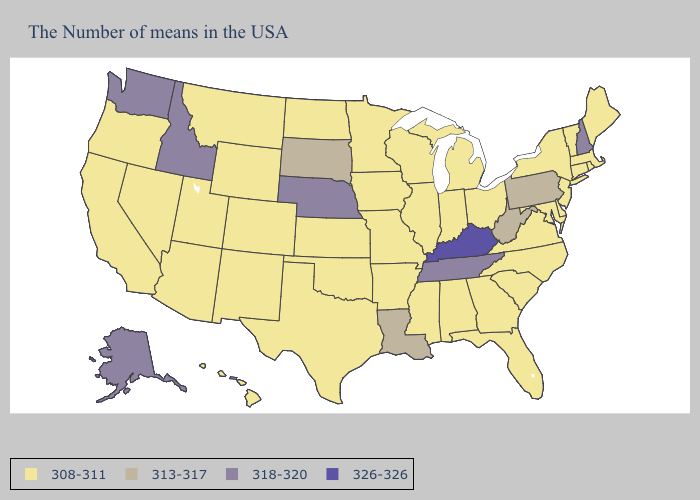Name the states that have a value in the range 313-317?
Write a very short answer. Pennsylvania, West Virginia, Louisiana, South Dakota. Does Alabama have the highest value in the USA?
Give a very brief answer. No. What is the highest value in the USA?
Short answer required. 326-326. Name the states that have a value in the range 326-326?
Answer briefly. Kentucky. Does the first symbol in the legend represent the smallest category?
Concise answer only. Yes. Name the states that have a value in the range 308-311?
Be succinct. Maine, Massachusetts, Rhode Island, Vermont, Connecticut, New York, New Jersey, Delaware, Maryland, Virginia, North Carolina, South Carolina, Ohio, Florida, Georgia, Michigan, Indiana, Alabama, Wisconsin, Illinois, Mississippi, Missouri, Arkansas, Minnesota, Iowa, Kansas, Oklahoma, Texas, North Dakota, Wyoming, Colorado, New Mexico, Utah, Montana, Arizona, Nevada, California, Oregon, Hawaii. What is the value of Arkansas?
Quick response, please. 308-311. Which states have the lowest value in the USA?
Concise answer only. Maine, Massachusetts, Rhode Island, Vermont, Connecticut, New York, New Jersey, Delaware, Maryland, Virginia, North Carolina, South Carolina, Ohio, Florida, Georgia, Michigan, Indiana, Alabama, Wisconsin, Illinois, Mississippi, Missouri, Arkansas, Minnesota, Iowa, Kansas, Oklahoma, Texas, North Dakota, Wyoming, Colorado, New Mexico, Utah, Montana, Arizona, Nevada, California, Oregon, Hawaii. Does Idaho have the lowest value in the USA?
Quick response, please. No. What is the value of New Jersey?
Concise answer only. 308-311. What is the value of South Carolina?
Keep it brief. 308-311. Does Louisiana have the lowest value in the USA?
Be succinct. No. What is the value of Oregon?
Quick response, please. 308-311. Does Nebraska have the lowest value in the MidWest?
Quick response, please. No. 